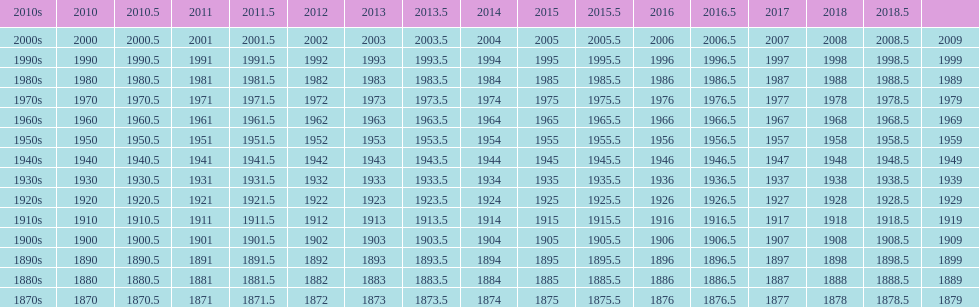What is the earliest year that a film was released? 1870. 